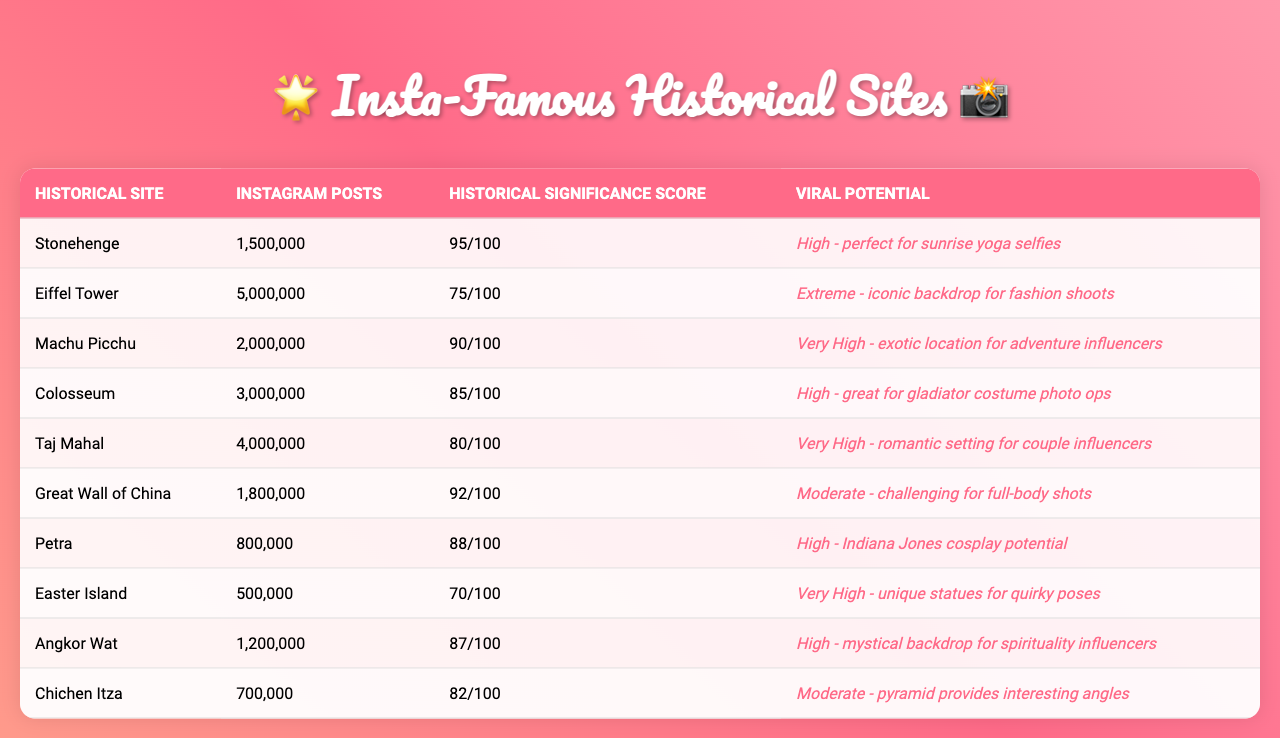What is the historical significance score of the Eiffel Tower? The table shows that the historical significance score of the Eiffel Tower is 75.
Answer: 75 How many Instagram posts does Chichen Itza have? According to the table, Chichen Itza has 700,000 Instagram posts.
Answer: 700,000 Which site has the highest historical significance score? The site with the highest historical significance score is Stonehenge, with a score of 95.
Answer: Stonehenge What is the total number of Instagram posts for the Great Wall of China and Petra combined? To find the total, we add the Instagram posts for both sites: 1,800,000 (Great Wall) + 800,000 (Petra) = 2,600,000.
Answer: 2,600,000 Is the viral potential for Machu Picchu classified as "Very High"? Yes, the viral potential for Machu Picchu is classified as "Very High" according to the table.
Answer: Yes What is the average historical significance score of the sites listed in the table? To calculate the average, we sum the historical significance scores: (95 + 75 + 90 + 85 + 80 + 92 + 88 + 70 + 87 + 82) = 909. Then we divide by the number of sites (10): 909/10 = 90.9.
Answer: 90.9 Which historical site has the least number of Instagram posts, and what is that number? The site with the least number of Instagram posts is Easter Island, with 500,000 posts.
Answer: Easter Island, 500,000 How does the historical significance score of the Taj Mahal compare to that of the Colosseum? The Taj Mahal has a historical significance score of 80, while the Colosseum has a score of 85. Since 80 is less than 85, the Taj Mahal's score is lower.
Answer: Lower What is the difference between the Instagram posts of the Colosseum and Machu Picchu? To find the difference, subtract Machu Picchu's posts (2,000,000) from the Colosseum's (3,000,000): 3,000,000 - 2,000,000 = 1,000,000.
Answer: 1,000,000 Is it true that the Great Wall of China has more Instagram posts than Stonehenge? Yes, the Great Wall of China has 1,800,000 posts, which is more than Stonehenge's 1,500,000 posts.
Answer: Yes 